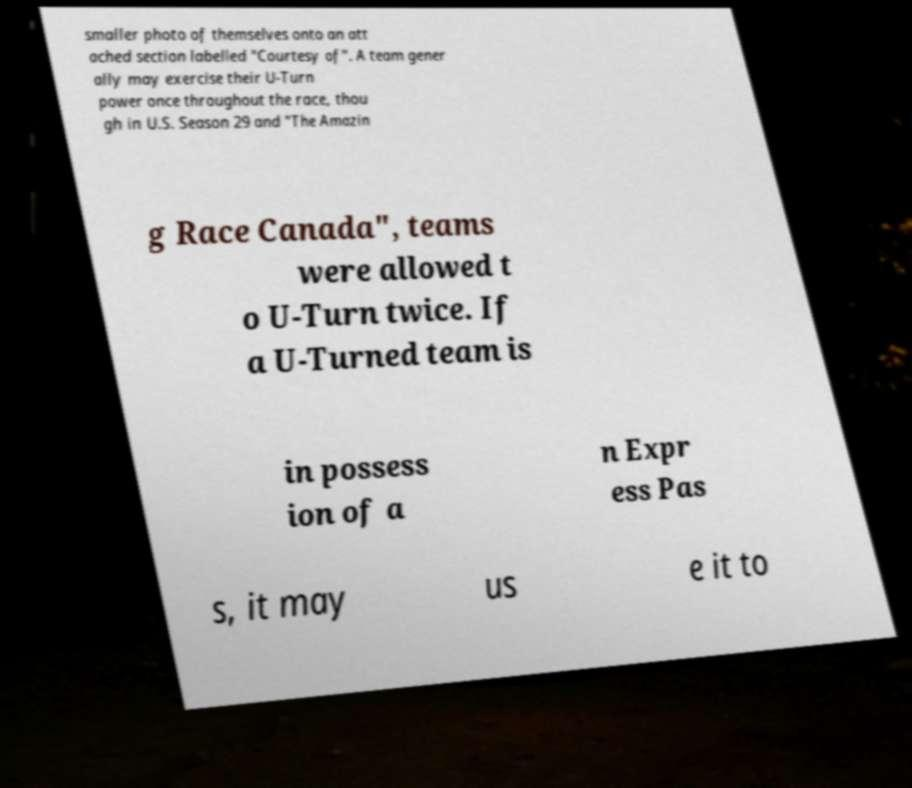Please read and relay the text visible in this image. What does it say? smaller photo of themselves onto an att ached section labelled "Courtesy of". A team gener ally may exercise their U-Turn power once throughout the race, thou gh in U.S. Season 29 and "The Amazin g Race Canada", teams were allowed t o U-Turn twice. If a U-Turned team is in possess ion of a n Expr ess Pas s, it may us e it to 